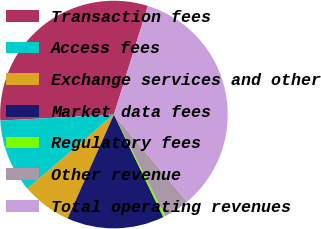Convert chart. <chart><loc_0><loc_0><loc_500><loc_500><pie_chart><fcel>Transaction fees<fcel>Access fees<fcel>Exchange services and other<fcel>Market data fees<fcel>Regulatory fees<fcel>Other revenue<fcel>Total operating revenues<nl><fcel>30.66%<fcel>10.43%<fcel>7.05%<fcel>13.81%<fcel>0.3%<fcel>3.68%<fcel>34.06%<nl></chart> 